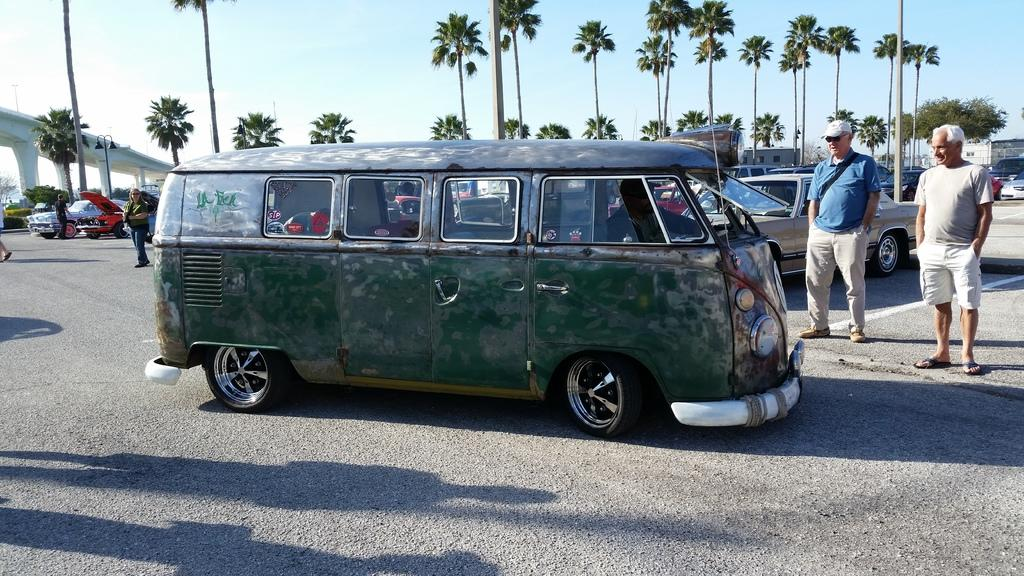What is the main feature of the image? There is a road in the image. What vehicle is on the road? There is a van on the road. Are there any people near the van? Yes, two men are standing beside the van. What can be seen in the background of the image? There are cars, trees, and a bridge visible in the background. What is the color of the sky in the image? The sky is blue in the image. Can you see a family playing with a hose near the bridge in the image? There is no family or hose present in the image. What type of waves can be seen crashing against the shore in the image? There is no shore or waves present in the image. 